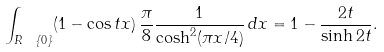<formula> <loc_0><loc_0><loc_500><loc_500>\int _ { R \ \{ 0 \} } ( 1 - \cos t x ) \, \frac { \pi } { 8 } \frac { 1 } { \cosh ^ { 2 } ( \pi x / 4 ) } \, d x = 1 - \frac { 2 t } { \sinh 2 t } .</formula> 